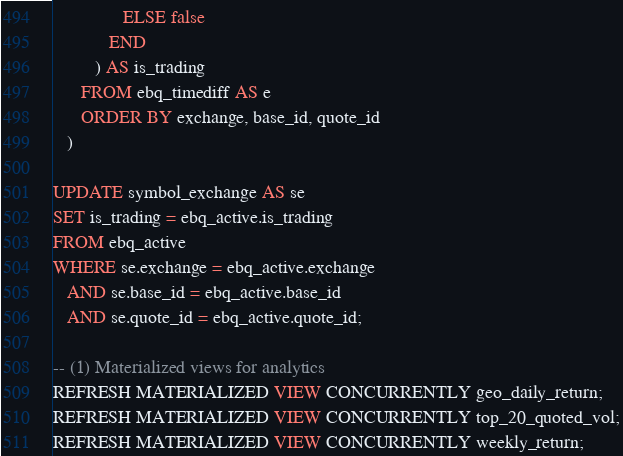<code> <loc_0><loc_0><loc_500><loc_500><_SQL_>               ELSE false
            END
         ) AS is_trading
      FROM ebq_timediff AS e
      ORDER BY exchange, base_id, quote_id
   )
   
UPDATE symbol_exchange AS se
SET is_trading = ebq_active.is_trading
FROM ebq_active
WHERE se.exchange = ebq_active.exchange
   AND se.base_id = ebq_active.base_id
   AND se.quote_id = ebq_active.quote_id;

-- (1) Materialized views for analytics
REFRESH MATERIALIZED VIEW CONCURRENTLY geo_daily_return;
REFRESH MATERIALIZED VIEW CONCURRENTLY top_20_quoted_vol;
REFRESH MATERIALIZED VIEW CONCURRENTLY weekly_return;
</code> 